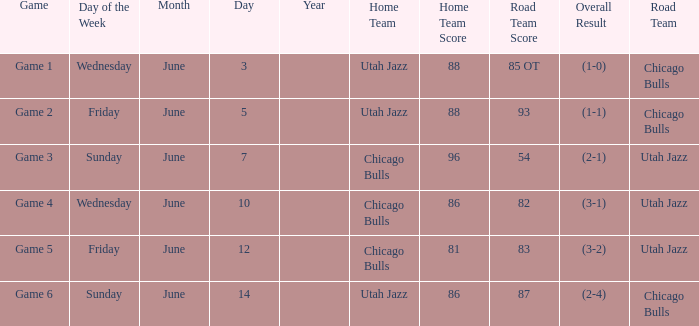Road Team of utah jazz, and a Result of 81-83 (3-2) involved what game? Game 5. 